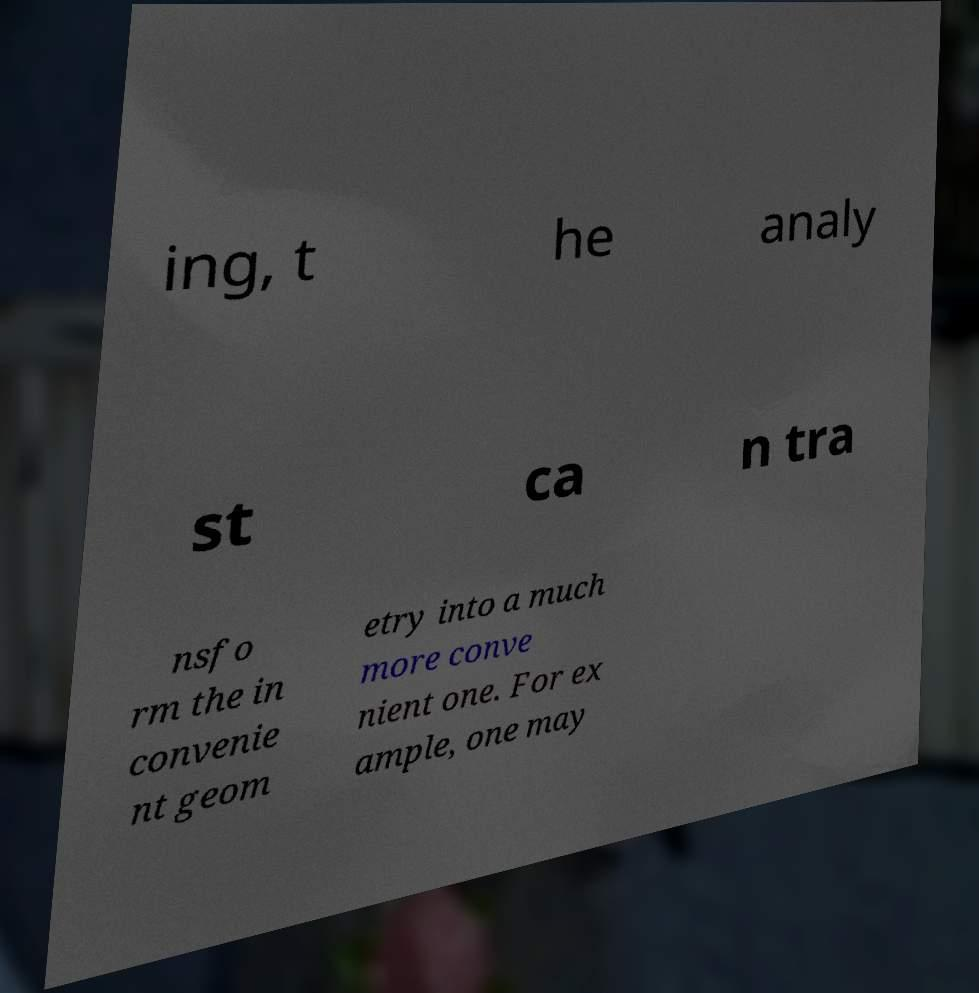Could you extract and type out the text from this image? ing, t he analy st ca n tra nsfo rm the in convenie nt geom etry into a much more conve nient one. For ex ample, one may 